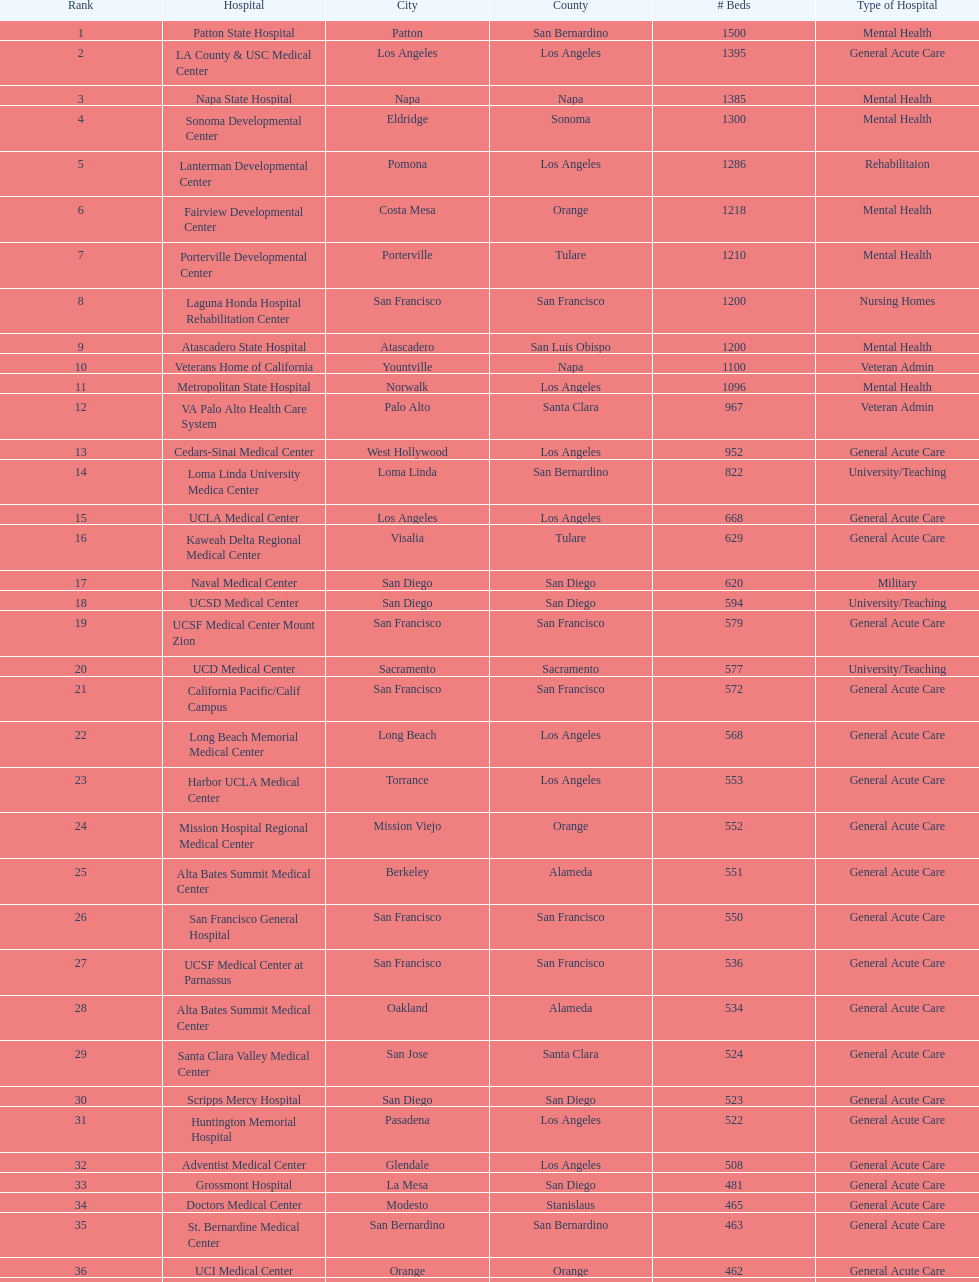Does patton state hospital in the city of patton in san bernardino county have more mental health hospital beds than atascadero state hospital in atascadero, san luis obispo county? Yes. 